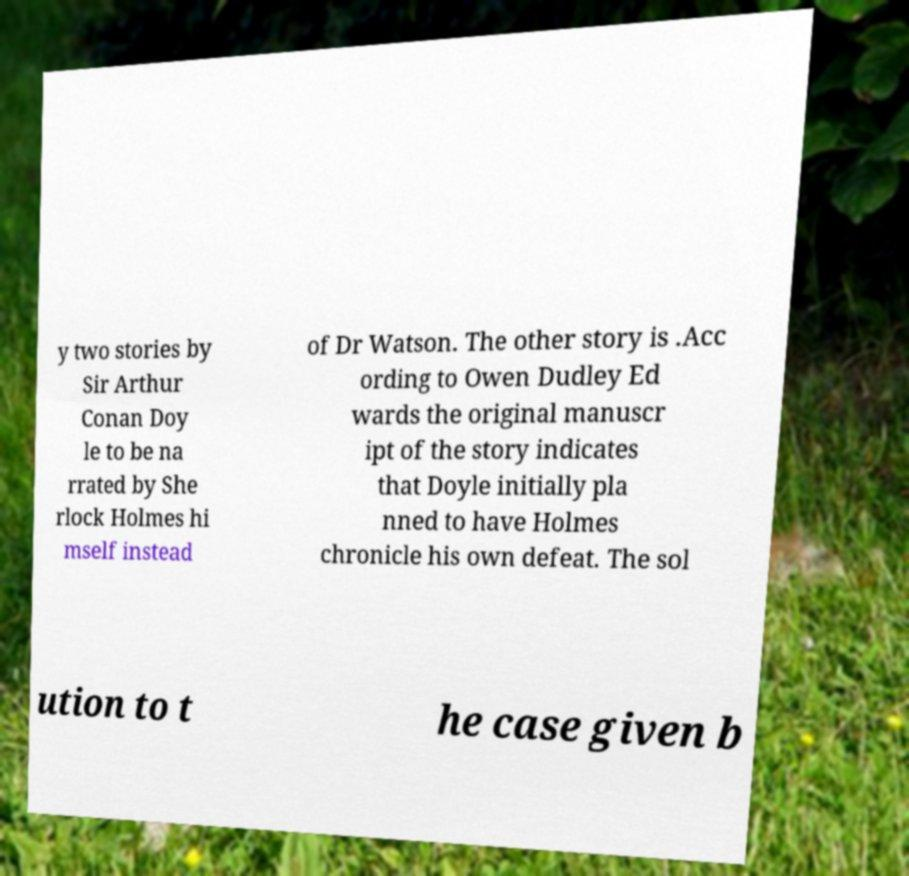Please identify and transcribe the text found in this image. y two stories by Sir Arthur Conan Doy le to be na rrated by She rlock Holmes hi mself instead of Dr Watson. The other story is .Acc ording to Owen Dudley Ed wards the original manuscr ipt of the story indicates that Doyle initially pla nned to have Holmes chronicle his own defeat. The sol ution to t he case given b 